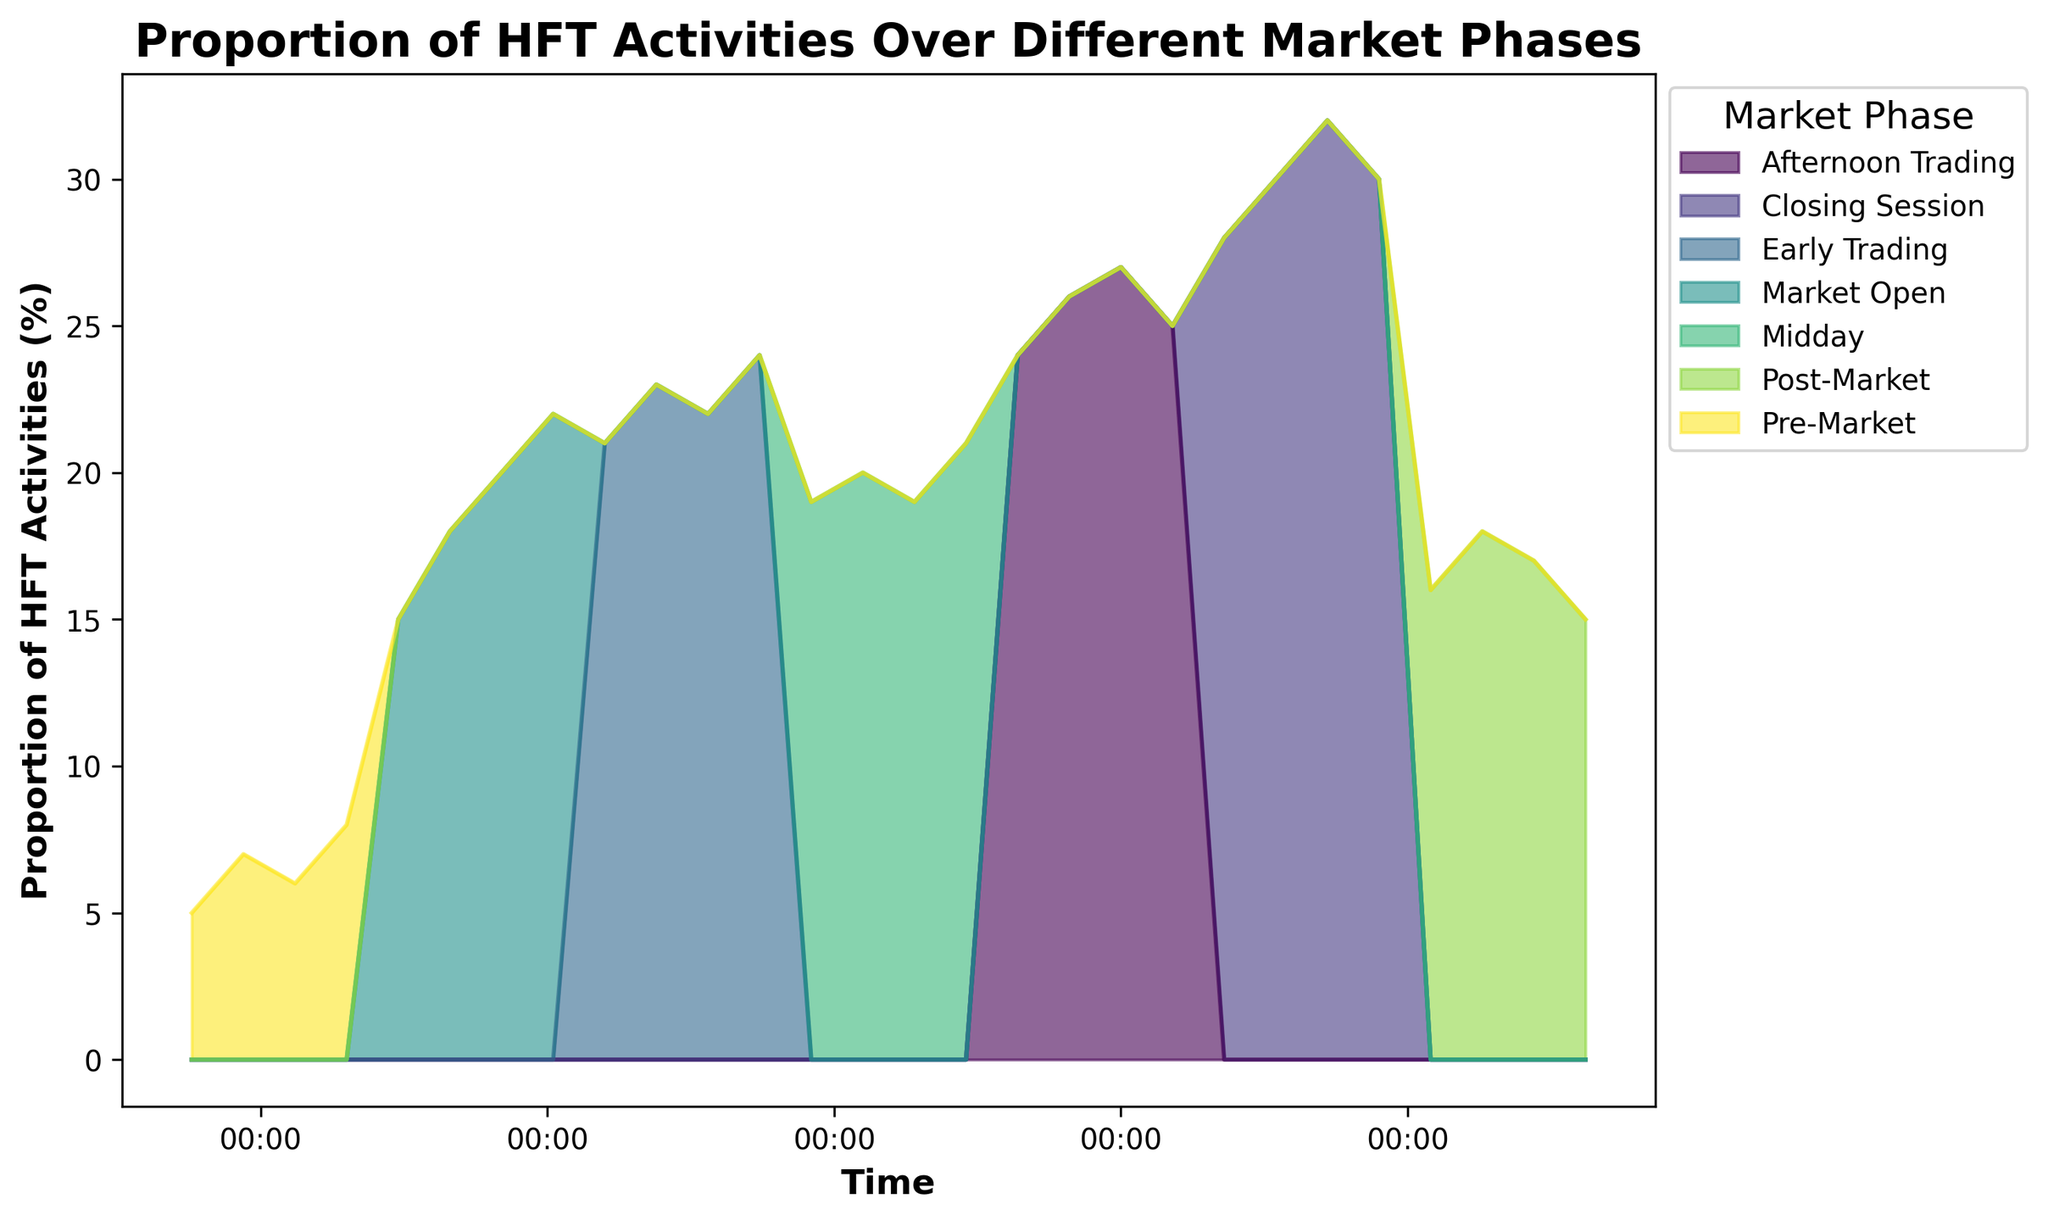What is the overall trend of HFT activities from the Pre-Market phase to the Closing Session? The overall trend shows a gradual increase in the proportion of HFT activities from the Pre-Market phase (5%-8%) to the Closing Session (28%-32%), peaking at around 32% during the Closing Session.
Answer: Gradual increase Which market phase has the highest proportion of HFT activities, and at what time does this occur? The Closing Session has the highest proportion of HFT activities, occurring at 13:30 with a value of 32%.
Answer: Closing Session at 13:30 During which market phase and at what time does the proportion of HFT activities start to decline? The decline starts in the Post-Market phase at 14:00, where the proportion drops from 30% to 16%.
Answer: Post-Market at 14:00 Compare the proportion of HFT activities during the Market Open phase at 09:30 and the Midday phase at 11:30. Which is higher and by how much? At 09:30 during the Market Open phase, the proportion is 20%, while at 11:30 during the Midday phase, it is 19%. Therefore, the Market Open proportion is higher by 1%.
Answer: Market Open by 1% What is the average proportion of HFT activities during the Early Trading phase? To find the average, sum the proportions (21% + 23% + 22% + 24% = 90%) and divide by the number of data points (90/4 = 22.5%).
Answer: 22.5% How does the proportion of HFT activities at 12:00 (Afternoon Trading) compare to that at 08:00 (Pre-Market)? At 12:00, the proportion is 24%, whereas, at 08:00, it is 5%. The proportion at 12:00 is significantly higher by 19%.
Answer: 12:00 is higher by 19% Is there any market phase where the proportion of HFT activities fluctuates significantly? Yes, the Afternoon Trading phase shows significant fluctuations, starting at 24%, peaking at 27%, then dropping to 25%.
Answer: Afternoon Trading Which market phase has the most stable proportion of HFT activities, and what is the range during this phase? The Midday phase is the most stable, with proportions ranging from 19% to 21%, showing little variation.
Answer: Midday, range 19%-21% What is the difference in the proportion of HFT activities between 10:45 (Early Trading) and 13:45 (Closing Session)? At 10:45, the proportion is 24%, while, at 13:45, it is 30%. The difference is 6%.
Answer: 6% 